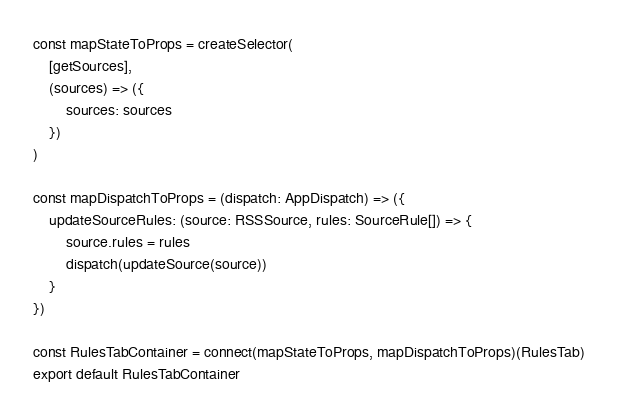<code> <loc_0><loc_0><loc_500><loc_500><_TypeScript_>
const mapStateToProps = createSelector(
    [getSources],
    (sources) => ({
        sources: sources
    })
)

const mapDispatchToProps = (dispatch: AppDispatch) => ({
    updateSourceRules: (source: RSSSource, rules: SourceRule[]) => {
        source.rules = rules
        dispatch(updateSource(source))
    }
})

const RulesTabContainer = connect(mapStateToProps, mapDispatchToProps)(RulesTab)
export default RulesTabContainer</code> 